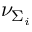Convert formula to latex. <formula><loc_0><loc_0><loc_500><loc_500>\nu _ { \Sigma _ { i } }</formula> 